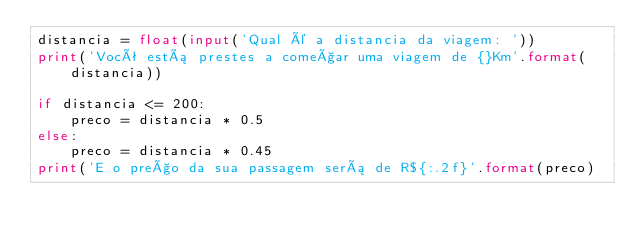Convert code to text. <code><loc_0><loc_0><loc_500><loc_500><_Python_>distancia = float(input('Qual é a distancia da viagem: '))
print('Você está prestes a começar uma viagem de {}Km'.format(distancia))

if distancia <= 200:
    preco = distancia * 0.5
else:
    preco = distancia * 0.45
print('E o preço da sua passagem será de R${:.2f}'.format(preco)
</code> 